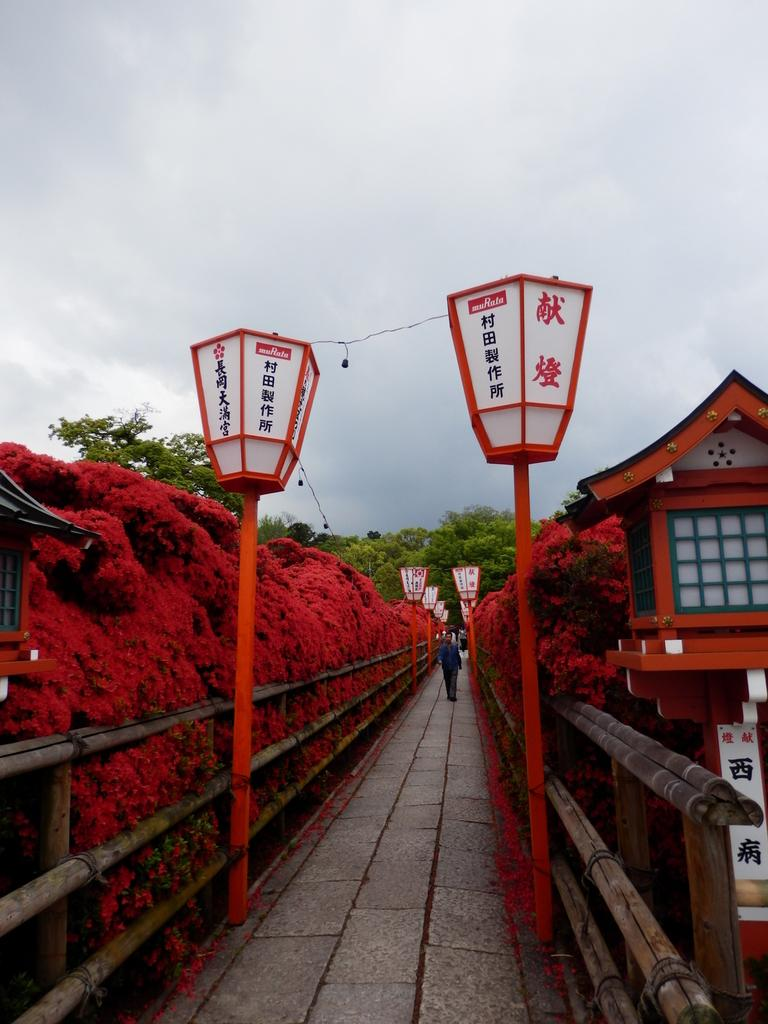Who or what is present in the image? There is a person in the image. What else can be seen in the image besides the person? There are plants and poles visible in the image. What is visible in the background of the image? There are trees and the sky visible in the background of the image. Where is the scarecrow located in the image? There is no scarecrow present in the image. What type of pig can be seen in the image? There is no pig present in the image. 